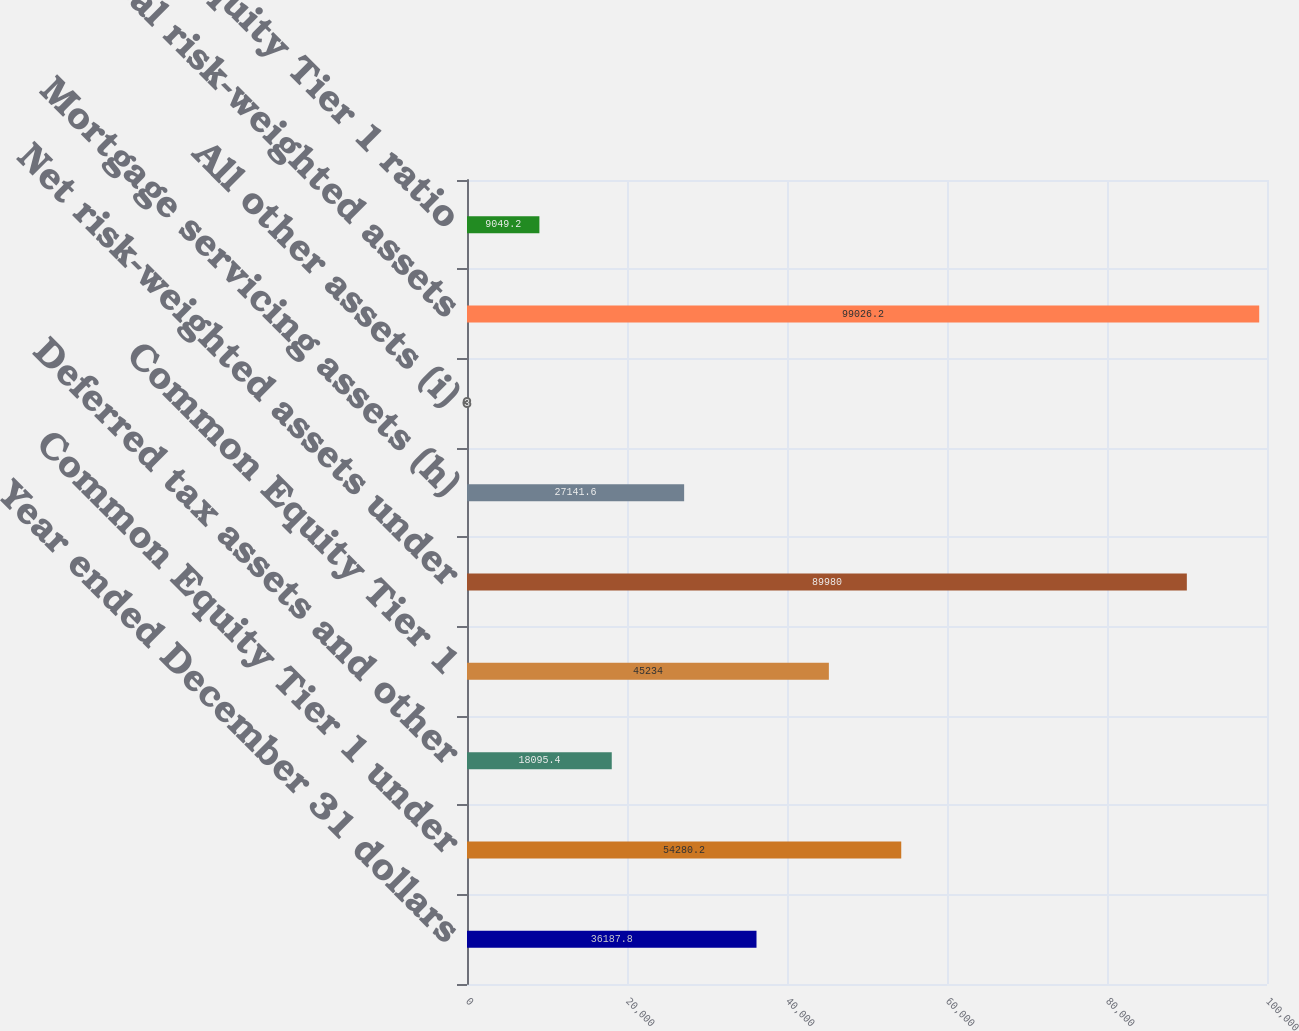Convert chart. <chart><loc_0><loc_0><loc_500><loc_500><bar_chart><fcel>Year ended December 31 dollars<fcel>Common Equity Tier 1 under<fcel>Deferred tax assets and other<fcel>Common Equity Tier 1<fcel>Net risk-weighted assets under<fcel>Mortgage servicing assets (h)<fcel>All other assets (i)<fcel>Total risk-weighted assets<fcel>Common Equity Tier 1 ratio<nl><fcel>36187.8<fcel>54280.2<fcel>18095.4<fcel>45234<fcel>89980<fcel>27141.6<fcel>3<fcel>99026.2<fcel>9049.2<nl></chart> 